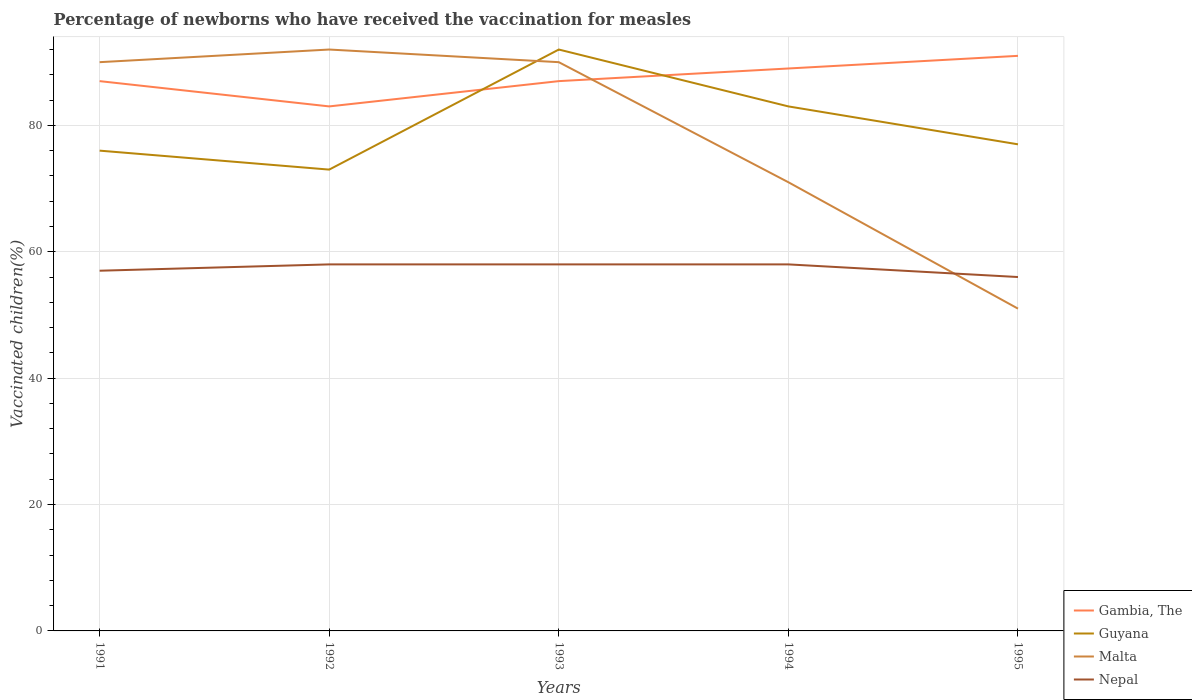Does the line corresponding to Gambia, The intersect with the line corresponding to Guyana?
Provide a short and direct response. Yes. Is the number of lines equal to the number of legend labels?
Provide a succinct answer. Yes. What is the total percentage of vaccinated children in Gambia, The in the graph?
Your response must be concise. -4. Is the percentage of vaccinated children in Nepal strictly greater than the percentage of vaccinated children in Gambia, The over the years?
Keep it short and to the point. Yes. How many years are there in the graph?
Ensure brevity in your answer.  5. Are the values on the major ticks of Y-axis written in scientific E-notation?
Your response must be concise. No. Does the graph contain grids?
Give a very brief answer. Yes. Where does the legend appear in the graph?
Your answer should be compact. Bottom right. How many legend labels are there?
Keep it short and to the point. 4. How are the legend labels stacked?
Provide a succinct answer. Vertical. What is the title of the graph?
Offer a very short reply. Percentage of newborns who have received the vaccination for measles. What is the label or title of the X-axis?
Keep it short and to the point. Years. What is the label or title of the Y-axis?
Your response must be concise. Vaccinated children(%). What is the Vaccinated children(%) of Gambia, The in 1991?
Your response must be concise. 87. What is the Vaccinated children(%) in Guyana in 1991?
Give a very brief answer. 76. What is the Vaccinated children(%) in Nepal in 1991?
Make the answer very short. 57. What is the Vaccinated children(%) of Guyana in 1992?
Your response must be concise. 73. What is the Vaccinated children(%) in Malta in 1992?
Your answer should be compact. 92. What is the Vaccinated children(%) in Nepal in 1992?
Ensure brevity in your answer.  58. What is the Vaccinated children(%) in Guyana in 1993?
Make the answer very short. 92. What is the Vaccinated children(%) of Malta in 1993?
Keep it short and to the point. 90. What is the Vaccinated children(%) in Nepal in 1993?
Your response must be concise. 58. What is the Vaccinated children(%) in Gambia, The in 1994?
Keep it short and to the point. 89. What is the Vaccinated children(%) of Guyana in 1994?
Ensure brevity in your answer.  83. What is the Vaccinated children(%) in Malta in 1994?
Ensure brevity in your answer.  71. What is the Vaccinated children(%) in Nepal in 1994?
Provide a succinct answer. 58. What is the Vaccinated children(%) in Gambia, The in 1995?
Offer a very short reply. 91. What is the Vaccinated children(%) in Malta in 1995?
Your answer should be very brief. 51. What is the Vaccinated children(%) in Nepal in 1995?
Ensure brevity in your answer.  56. Across all years, what is the maximum Vaccinated children(%) in Gambia, The?
Give a very brief answer. 91. Across all years, what is the maximum Vaccinated children(%) in Guyana?
Provide a short and direct response. 92. Across all years, what is the maximum Vaccinated children(%) in Malta?
Your answer should be compact. 92. Across all years, what is the minimum Vaccinated children(%) in Nepal?
Offer a terse response. 56. What is the total Vaccinated children(%) in Gambia, The in the graph?
Ensure brevity in your answer.  437. What is the total Vaccinated children(%) in Guyana in the graph?
Your answer should be compact. 401. What is the total Vaccinated children(%) in Malta in the graph?
Provide a short and direct response. 394. What is the total Vaccinated children(%) in Nepal in the graph?
Offer a terse response. 287. What is the difference between the Vaccinated children(%) in Guyana in 1991 and that in 1992?
Give a very brief answer. 3. What is the difference between the Vaccinated children(%) in Malta in 1991 and that in 1992?
Make the answer very short. -2. What is the difference between the Vaccinated children(%) in Nepal in 1991 and that in 1992?
Provide a short and direct response. -1. What is the difference between the Vaccinated children(%) in Malta in 1991 and that in 1993?
Offer a terse response. 0. What is the difference between the Vaccinated children(%) in Gambia, The in 1991 and that in 1994?
Offer a terse response. -2. What is the difference between the Vaccinated children(%) of Guyana in 1991 and that in 1994?
Provide a succinct answer. -7. What is the difference between the Vaccinated children(%) of Nepal in 1991 and that in 1995?
Offer a very short reply. 1. What is the difference between the Vaccinated children(%) in Gambia, The in 1992 and that in 1994?
Offer a terse response. -6. What is the difference between the Vaccinated children(%) of Nepal in 1992 and that in 1995?
Your answer should be compact. 2. What is the difference between the Vaccinated children(%) of Gambia, The in 1993 and that in 1994?
Offer a very short reply. -2. What is the difference between the Vaccinated children(%) in Guyana in 1993 and that in 1994?
Provide a short and direct response. 9. What is the difference between the Vaccinated children(%) of Nepal in 1993 and that in 1994?
Provide a succinct answer. 0. What is the difference between the Vaccinated children(%) in Nepal in 1993 and that in 1995?
Make the answer very short. 2. What is the difference between the Vaccinated children(%) of Gambia, The in 1994 and that in 1995?
Make the answer very short. -2. What is the difference between the Vaccinated children(%) of Guyana in 1994 and that in 1995?
Give a very brief answer. 6. What is the difference between the Vaccinated children(%) in Malta in 1994 and that in 1995?
Your answer should be compact. 20. What is the difference between the Vaccinated children(%) in Nepal in 1994 and that in 1995?
Offer a very short reply. 2. What is the difference between the Vaccinated children(%) of Gambia, The in 1991 and the Vaccinated children(%) of Nepal in 1992?
Keep it short and to the point. 29. What is the difference between the Vaccinated children(%) in Guyana in 1991 and the Vaccinated children(%) in Nepal in 1992?
Offer a very short reply. 18. What is the difference between the Vaccinated children(%) in Malta in 1991 and the Vaccinated children(%) in Nepal in 1992?
Your answer should be compact. 32. What is the difference between the Vaccinated children(%) of Gambia, The in 1991 and the Vaccinated children(%) of Guyana in 1993?
Your answer should be compact. -5. What is the difference between the Vaccinated children(%) in Gambia, The in 1991 and the Vaccinated children(%) in Malta in 1993?
Provide a succinct answer. -3. What is the difference between the Vaccinated children(%) of Gambia, The in 1991 and the Vaccinated children(%) of Guyana in 1994?
Provide a succinct answer. 4. What is the difference between the Vaccinated children(%) in Guyana in 1991 and the Vaccinated children(%) in Malta in 1994?
Give a very brief answer. 5. What is the difference between the Vaccinated children(%) of Malta in 1991 and the Vaccinated children(%) of Nepal in 1994?
Your answer should be compact. 32. What is the difference between the Vaccinated children(%) of Gambia, The in 1991 and the Vaccinated children(%) of Nepal in 1995?
Your answer should be compact. 31. What is the difference between the Vaccinated children(%) of Guyana in 1991 and the Vaccinated children(%) of Malta in 1995?
Your response must be concise. 25. What is the difference between the Vaccinated children(%) of Guyana in 1991 and the Vaccinated children(%) of Nepal in 1995?
Provide a succinct answer. 20. What is the difference between the Vaccinated children(%) in Gambia, The in 1992 and the Vaccinated children(%) in Guyana in 1993?
Provide a succinct answer. -9. What is the difference between the Vaccinated children(%) of Gambia, The in 1992 and the Vaccinated children(%) of Malta in 1993?
Offer a terse response. -7. What is the difference between the Vaccinated children(%) in Gambia, The in 1992 and the Vaccinated children(%) in Nepal in 1993?
Offer a terse response. 25. What is the difference between the Vaccinated children(%) in Malta in 1992 and the Vaccinated children(%) in Nepal in 1993?
Your answer should be compact. 34. What is the difference between the Vaccinated children(%) in Gambia, The in 1992 and the Vaccinated children(%) in Guyana in 1994?
Provide a short and direct response. 0. What is the difference between the Vaccinated children(%) of Gambia, The in 1992 and the Vaccinated children(%) of Malta in 1994?
Your answer should be compact. 12. What is the difference between the Vaccinated children(%) in Guyana in 1992 and the Vaccinated children(%) in Malta in 1994?
Provide a short and direct response. 2. What is the difference between the Vaccinated children(%) in Malta in 1992 and the Vaccinated children(%) in Nepal in 1994?
Ensure brevity in your answer.  34. What is the difference between the Vaccinated children(%) of Gambia, The in 1992 and the Vaccinated children(%) of Guyana in 1995?
Offer a terse response. 6. What is the difference between the Vaccinated children(%) in Gambia, The in 1992 and the Vaccinated children(%) in Malta in 1995?
Your answer should be very brief. 32. What is the difference between the Vaccinated children(%) of Gambia, The in 1992 and the Vaccinated children(%) of Nepal in 1995?
Offer a terse response. 27. What is the difference between the Vaccinated children(%) of Guyana in 1992 and the Vaccinated children(%) of Malta in 1995?
Your response must be concise. 22. What is the difference between the Vaccinated children(%) in Guyana in 1992 and the Vaccinated children(%) in Nepal in 1995?
Make the answer very short. 17. What is the difference between the Vaccinated children(%) in Gambia, The in 1993 and the Vaccinated children(%) in Malta in 1994?
Your response must be concise. 16. What is the difference between the Vaccinated children(%) in Gambia, The in 1993 and the Vaccinated children(%) in Nepal in 1994?
Your answer should be compact. 29. What is the difference between the Vaccinated children(%) in Guyana in 1993 and the Vaccinated children(%) in Malta in 1994?
Offer a terse response. 21. What is the difference between the Vaccinated children(%) in Guyana in 1993 and the Vaccinated children(%) in Nepal in 1994?
Keep it short and to the point. 34. What is the difference between the Vaccinated children(%) in Gambia, The in 1993 and the Vaccinated children(%) in Guyana in 1995?
Make the answer very short. 10. What is the difference between the Vaccinated children(%) in Guyana in 1993 and the Vaccinated children(%) in Malta in 1995?
Give a very brief answer. 41. What is the difference between the Vaccinated children(%) in Malta in 1993 and the Vaccinated children(%) in Nepal in 1995?
Your response must be concise. 34. What is the difference between the Vaccinated children(%) in Gambia, The in 1994 and the Vaccinated children(%) in Guyana in 1995?
Your answer should be compact. 12. What is the difference between the Vaccinated children(%) in Gambia, The in 1994 and the Vaccinated children(%) in Malta in 1995?
Keep it short and to the point. 38. What is the difference between the Vaccinated children(%) in Guyana in 1994 and the Vaccinated children(%) in Nepal in 1995?
Offer a very short reply. 27. What is the average Vaccinated children(%) in Gambia, The per year?
Offer a terse response. 87.4. What is the average Vaccinated children(%) of Guyana per year?
Provide a succinct answer. 80.2. What is the average Vaccinated children(%) of Malta per year?
Keep it short and to the point. 78.8. What is the average Vaccinated children(%) of Nepal per year?
Ensure brevity in your answer.  57.4. In the year 1991, what is the difference between the Vaccinated children(%) of Gambia, The and Vaccinated children(%) of Guyana?
Offer a very short reply. 11. In the year 1991, what is the difference between the Vaccinated children(%) in Gambia, The and Vaccinated children(%) in Malta?
Provide a short and direct response. -3. In the year 1991, what is the difference between the Vaccinated children(%) in Guyana and Vaccinated children(%) in Malta?
Ensure brevity in your answer.  -14. In the year 1992, what is the difference between the Vaccinated children(%) in Gambia, The and Vaccinated children(%) in Guyana?
Your answer should be very brief. 10. In the year 1992, what is the difference between the Vaccinated children(%) in Gambia, The and Vaccinated children(%) in Nepal?
Give a very brief answer. 25. In the year 1992, what is the difference between the Vaccinated children(%) of Guyana and Vaccinated children(%) of Malta?
Give a very brief answer. -19. In the year 1993, what is the difference between the Vaccinated children(%) of Gambia, The and Vaccinated children(%) of Guyana?
Your answer should be compact. -5. In the year 1993, what is the difference between the Vaccinated children(%) of Guyana and Vaccinated children(%) of Malta?
Ensure brevity in your answer.  2. In the year 1994, what is the difference between the Vaccinated children(%) of Gambia, The and Vaccinated children(%) of Malta?
Offer a terse response. 18. In the year 1994, what is the difference between the Vaccinated children(%) of Gambia, The and Vaccinated children(%) of Nepal?
Your response must be concise. 31. In the year 1994, what is the difference between the Vaccinated children(%) of Malta and Vaccinated children(%) of Nepal?
Keep it short and to the point. 13. In the year 1995, what is the difference between the Vaccinated children(%) in Malta and Vaccinated children(%) in Nepal?
Provide a short and direct response. -5. What is the ratio of the Vaccinated children(%) in Gambia, The in 1991 to that in 1992?
Provide a short and direct response. 1.05. What is the ratio of the Vaccinated children(%) in Guyana in 1991 to that in 1992?
Make the answer very short. 1.04. What is the ratio of the Vaccinated children(%) of Malta in 1991 to that in 1992?
Provide a short and direct response. 0.98. What is the ratio of the Vaccinated children(%) in Nepal in 1991 to that in 1992?
Your answer should be very brief. 0.98. What is the ratio of the Vaccinated children(%) in Guyana in 1991 to that in 1993?
Ensure brevity in your answer.  0.83. What is the ratio of the Vaccinated children(%) of Malta in 1991 to that in 1993?
Offer a very short reply. 1. What is the ratio of the Vaccinated children(%) of Nepal in 1991 to that in 1993?
Provide a succinct answer. 0.98. What is the ratio of the Vaccinated children(%) in Gambia, The in 1991 to that in 1994?
Your answer should be compact. 0.98. What is the ratio of the Vaccinated children(%) of Guyana in 1991 to that in 1994?
Provide a short and direct response. 0.92. What is the ratio of the Vaccinated children(%) of Malta in 1991 to that in 1994?
Make the answer very short. 1.27. What is the ratio of the Vaccinated children(%) in Nepal in 1991 to that in 1994?
Make the answer very short. 0.98. What is the ratio of the Vaccinated children(%) in Gambia, The in 1991 to that in 1995?
Ensure brevity in your answer.  0.96. What is the ratio of the Vaccinated children(%) of Malta in 1991 to that in 1995?
Your answer should be very brief. 1.76. What is the ratio of the Vaccinated children(%) in Nepal in 1991 to that in 1995?
Offer a terse response. 1.02. What is the ratio of the Vaccinated children(%) of Gambia, The in 1992 to that in 1993?
Provide a succinct answer. 0.95. What is the ratio of the Vaccinated children(%) in Guyana in 1992 to that in 1993?
Your answer should be compact. 0.79. What is the ratio of the Vaccinated children(%) of Malta in 1992 to that in 1993?
Provide a succinct answer. 1.02. What is the ratio of the Vaccinated children(%) in Gambia, The in 1992 to that in 1994?
Offer a terse response. 0.93. What is the ratio of the Vaccinated children(%) in Guyana in 1992 to that in 1994?
Give a very brief answer. 0.88. What is the ratio of the Vaccinated children(%) of Malta in 1992 to that in 1994?
Your answer should be very brief. 1.3. What is the ratio of the Vaccinated children(%) in Nepal in 1992 to that in 1994?
Give a very brief answer. 1. What is the ratio of the Vaccinated children(%) of Gambia, The in 1992 to that in 1995?
Your answer should be very brief. 0.91. What is the ratio of the Vaccinated children(%) of Guyana in 1992 to that in 1995?
Offer a very short reply. 0.95. What is the ratio of the Vaccinated children(%) in Malta in 1992 to that in 1995?
Offer a very short reply. 1.8. What is the ratio of the Vaccinated children(%) in Nepal in 1992 to that in 1995?
Keep it short and to the point. 1.04. What is the ratio of the Vaccinated children(%) in Gambia, The in 1993 to that in 1994?
Give a very brief answer. 0.98. What is the ratio of the Vaccinated children(%) of Guyana in 1993 to that in 1994?
Provide a short and direct response. 1.11. What is the ratio of the Vaccinated children(%) of Malta in 1993 to that in 1994?
Your response must be concise. 1.27. What is the ratio of the Vaccinated children(%) in Gambia, The in 1993 to that in 1995?
Offer a terse response. 0.96. What is the ratio of the Vaccinated children(%) in Guyana in 1993 to that in 1995?
Give a very brief answer. 1.19. What is the ratio of the Vaccinated children(%) of Malta in 1993 to that in 1995?
Give a very brief answer. 1.76. What is the ratio of the Vaccinated children(%) of Nepal in 1993 to that in 1995?
Ensure brevity in your answer.  1.04. What is the ratio of the Vaccinated children(%) of Guyana in 1994 to that in 1995?
Give a very brief answer. 1.08. What is the ratio of the Vaccinated children(%) in Malta in 1994 to that in 1995?
Offer a terse response. 1.39. What is the ratio of the Vaccinated children(%) in Nepal in 1994 to that in 1995?
Provide a short and direct response. 1.04. What is the difference between the highest and the second highest Vaccinated children(%) of Nepal?
Offer a very short reply. 0. What is the difference between the highest and the lowest Vaccinated children(%) of Gambia, The?
Provide a succinct answer. 8. What is the difference between the highest and the lowest Vaccinated children(%) of Malta?
Your response must be concise. 41. 